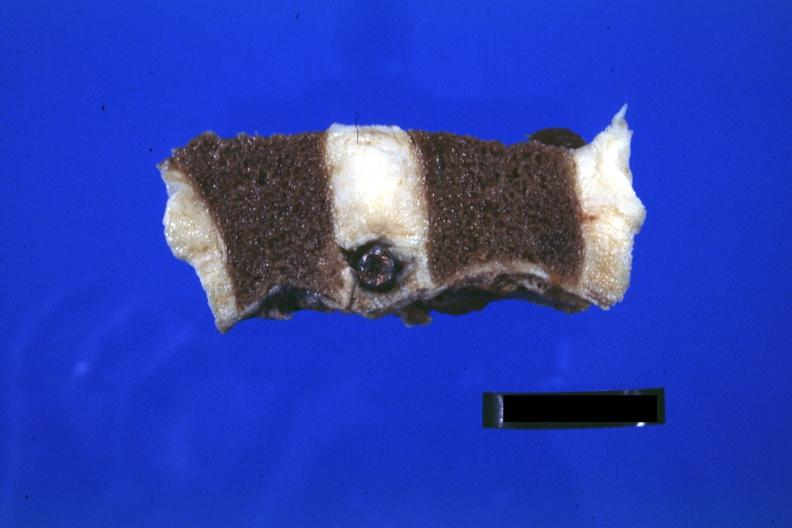does this image show close-up view well shown?
Answer the question using a single word or phrase. Yes 